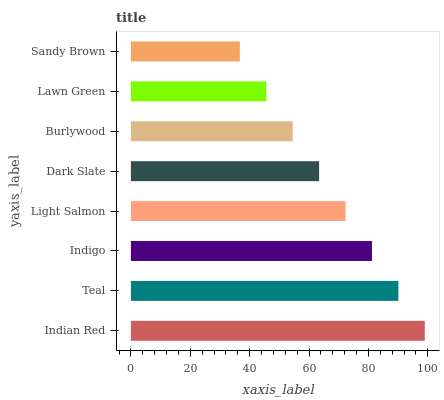Is Sandy Brown the minimum?
Answer yes or no. Yes. Is Indian Red the maximum?
Answer yes or no. Yes. Is Teal the minimum?
Answer yes or no. No. Is Teal the maximum?
Answer yes or no. No. Is Indian Red greater than Teal?
Answer yes or no. Yes. Is Teal less than Indian Red?
Answer yes or no. Yes. Is Teal greater than Indian Red?
Answer yes or no. No. Is Indian Red less than Teal?
Answer yes or no. No. Is Light Salmon the high median?
Answer yes or no. Yes. Is Dark Slate the low median?
Answer yes or no. Yes. Is Indigo the high median?
Answer yes or no. No. Is Indigo the low median?
Answer yes or no. No. 